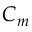Convert formula to latex. <formula><loc_0><loc_0><loc_500><loc_500>C _ { m }</formula> 